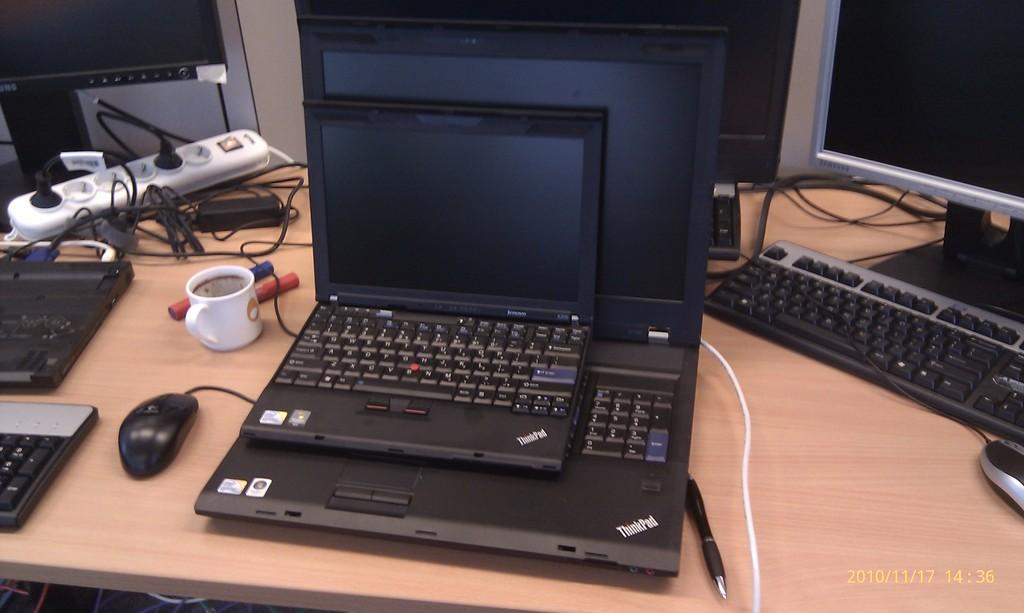<image>
Summarize the visual content of the image. the word ThinkPad is on the black item on the desk 